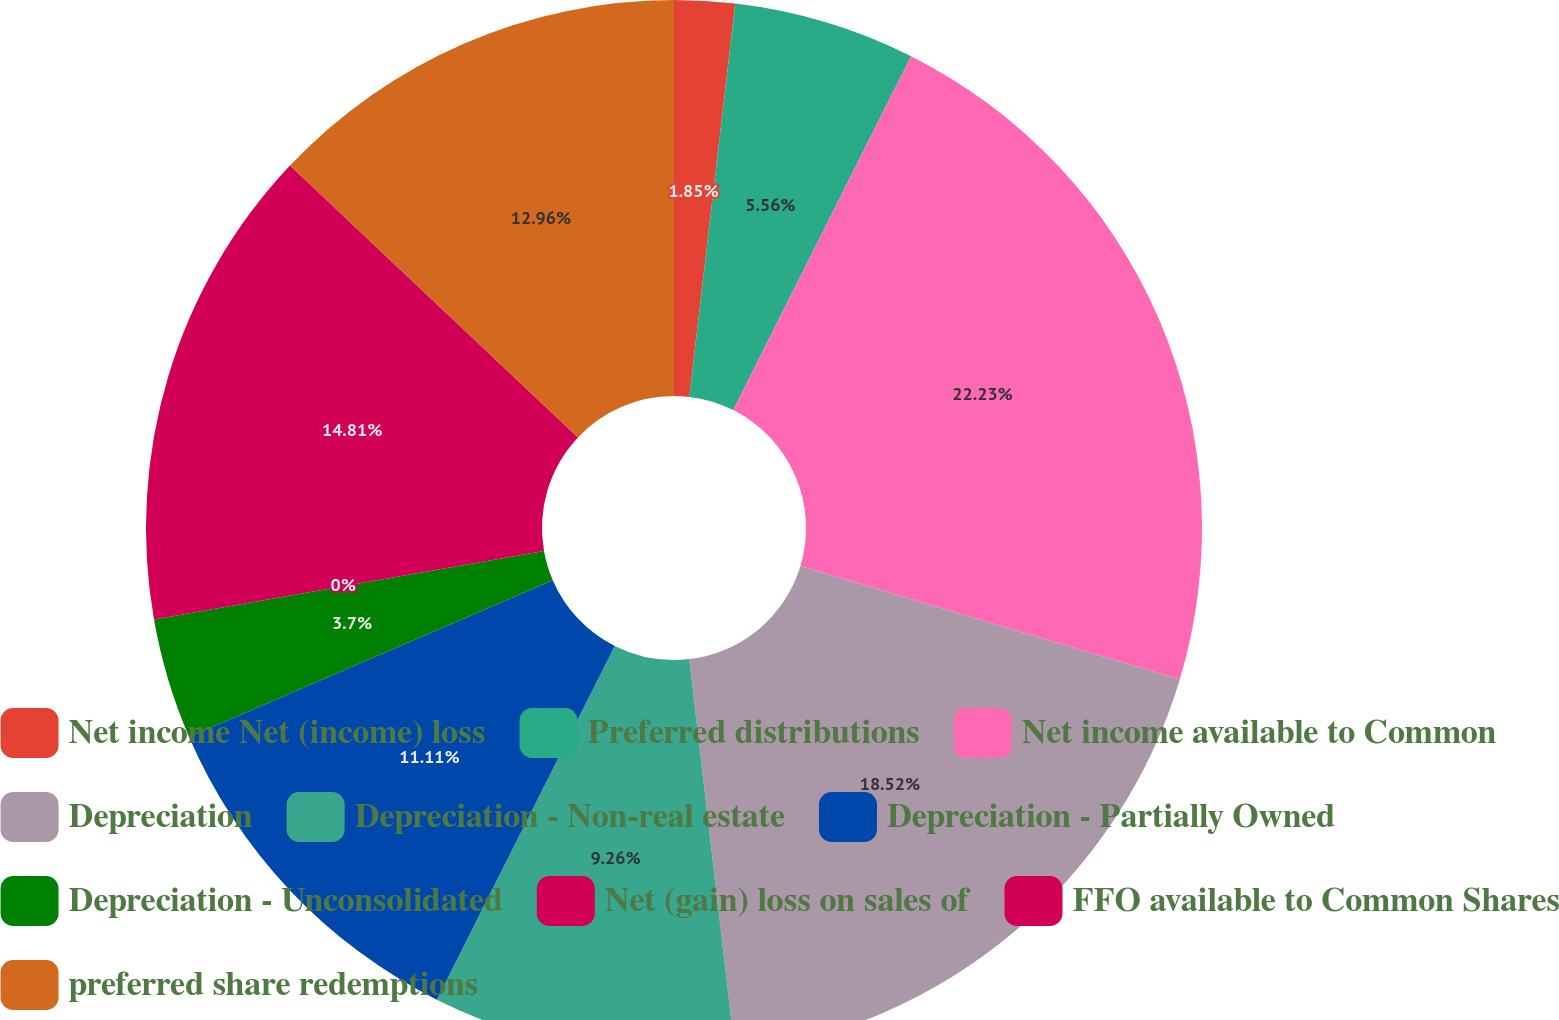Convert chart. <chart><loc_0><loc_0><loc_500><loc_500><pie_chart><fcel>Net income Net (income) loss<fcel>Preferred distributions<fcel>Net income available to Common<fcel>Depreciation<fcel>Depreciation - Non-real estate<fcel>Depreciation - Partially Owned<fcel>Depreciation - Unconsolidated<fcel>Net (gain) loss on sales of<fcel>FFO available to Common Shares<fcel>preferred share redemptions<nl><fcel>1.85%<fcel>5.56%<fcel>22.22%<fcel>18.52%<fcel>9.26%<fcel>11.11%<fcel>3.7%<fcel>0.0%<fcel>14.81%<fcel>12.96%<nl></chart> 